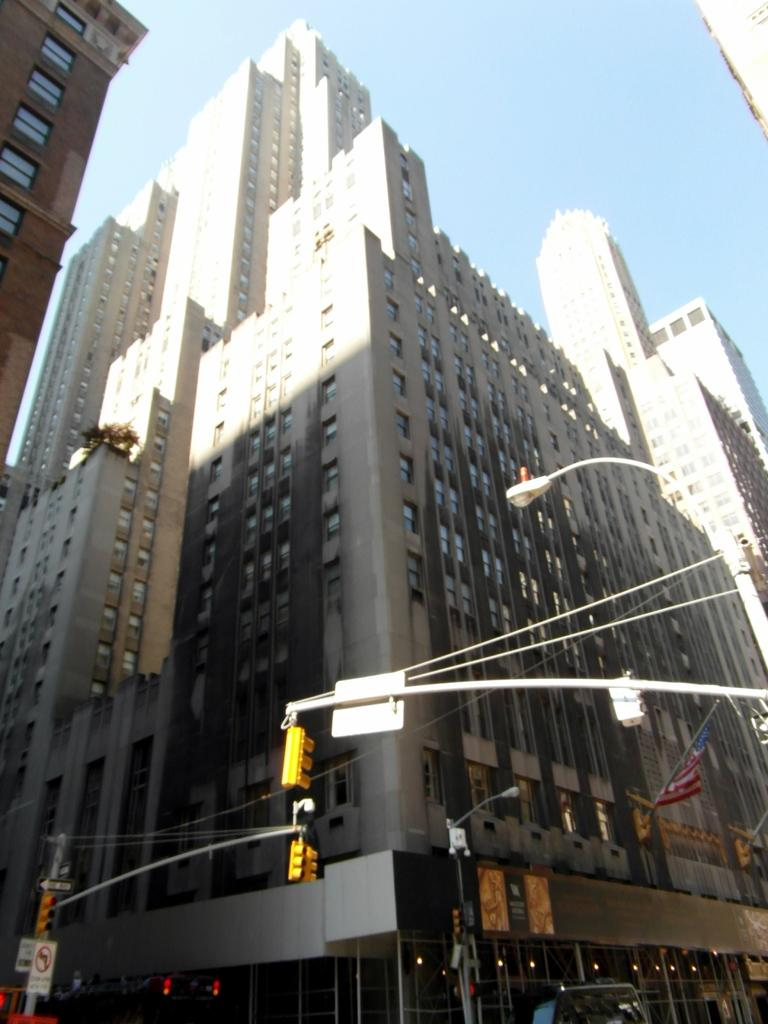What type of structures can be seen in the image? There are buildings in the image. What other objects are present in the image? There are poles, signals, and streetlights in the image. What can be seen in the sky in the image? The sky is visible in the image. What type of card is being used by the deer in the image? There are no cards or deer present in the image. 